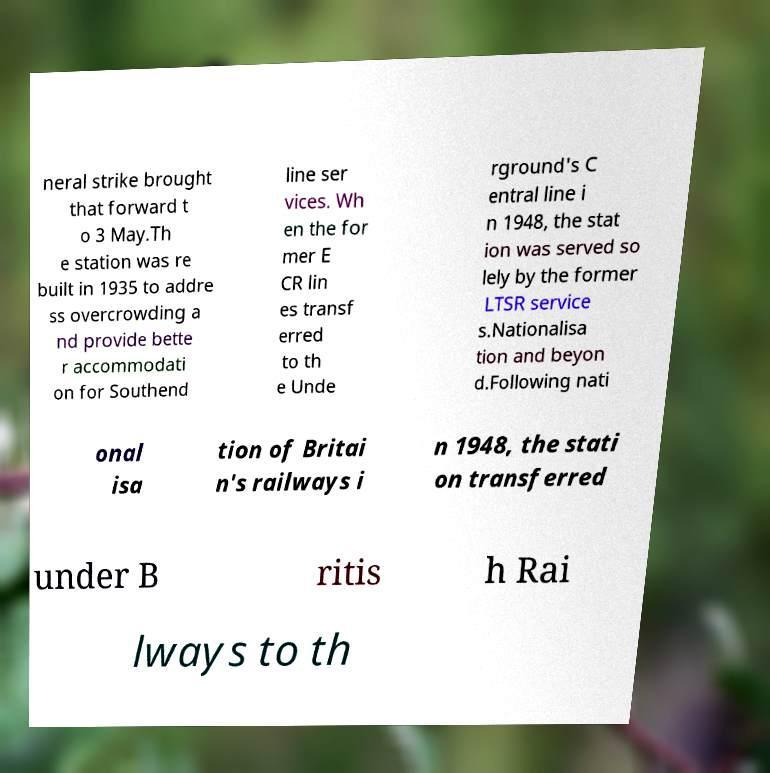Can you read and provide the text displayed in the image?This photo seems to have some interesting text. Can you extract and type it out for me? neral strike brought that forward t o 3 May.Th e station was re built in 1935 to addre ss overcrowding a nd provide bette r accommodati on for Southend line ser vices. Wh en the for mer E CR lin es transf erred to th e Unde rground's C entral line i n 1948, the stat ion was served so lely by the former LTSR service s.Nationalisa tion and beyon d.Following nati onal isa tion of Britai n's railways i n 1948, the stati on transferred under B ritis h Rai lways to th 